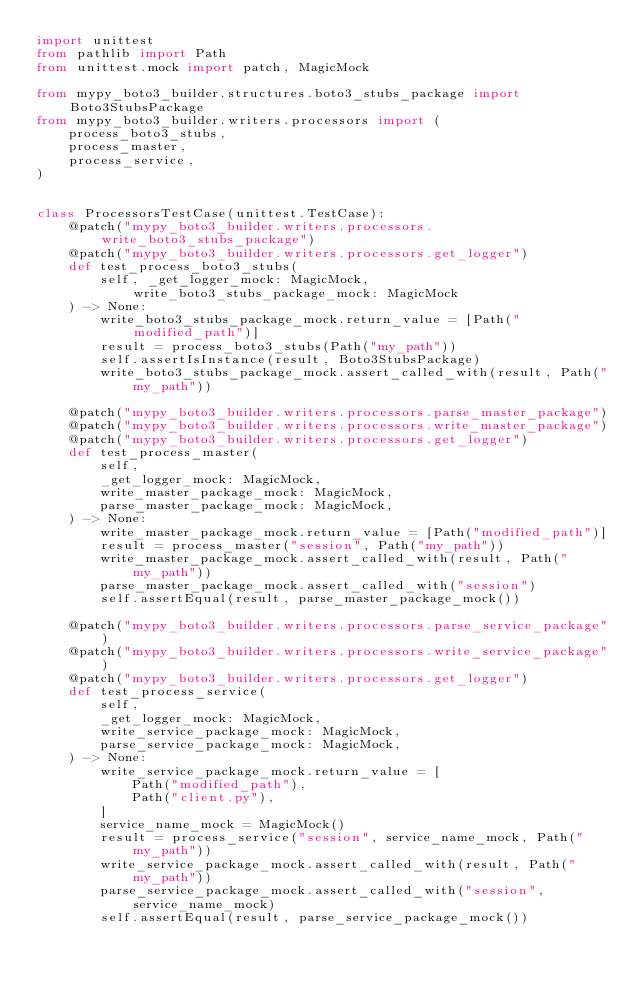<code> <loc_0><loc_0><loc_500><loc_500><_Python_>import unittest
from pathlib import Path
from unittest.mock import patch, MagicMock

from mypy_boto3_builder.structures.boto3_stubs_package import Boto3StubsPackage
from mypy_boto3_builder.writers.processors import (
    process_boto3_stubs,
    process_master,
    process_service,
)


class ProcessorsTestCase(unittest.TestCase):
    @patch("mypy_boto3_builder.writers.processors.write_boto3_stubs_package")
    @patch("mypy_boto3_builder.writers.processors.get_logger")
    def test_process_boto3_stubs(
        self, _get_logger_mock: MagicMock, write_boto3_stubs_package_mock: MagicMock
    ) -> None:
        write_boto3_stubs_package_mock.return_value = [Path("modified_path")]
        result = process_boto3_stubs(Path("my_path"))
        self.assertIsInstance(result, Boto3StubsPackage)
        write_boto3_stubs_package_mock.assert_called_with(result, Path("my_path"))

    @patch("mypy_boto3_builder.writers.processors.parse_master_package")
    @patch("mypy_boto3_builder.writers.processors.write_master_package")
    @patch("mypy_boto3_builder.writers.processors.get_logger")
    def test_process_master(
        self,
        _get_logger_mock: MagicMock,
        write_master_package_mock: MagicMock,
        parse_master_package_mock: MagicMock,
    ) -> None:
        write_master_package_mock.return_value = [Path("modified_path")]
        result = process_master("session", Path("my_path"))
        write_master_package_mock.assert_called_with(result, Path("my_path"))
        parse_master_package_mock.assert_called_with("session")
        self.assertEqual(result, parse_master_package_mock())

    @patch("mypy_boto3_builder.writers.processors.parse_service_package")
    @patch("mypy_boto3_builder.writers.processors.write_service_package")
    @patch("mypy_boto3_builder.writers.processors.get_logger")
    def test_process_service(
        self,
        _get_logger_mock: MagicMock,
        write_service_package_mock: MagicMock,
        parse_service_package_mock: MagicMock,
    ) -> None:
        write_service_package_mock.return_value = [
            Path("modified_path"),
            Path("client.py"),
        ]
        service_name_mock = MagicMock()
        result = process_service("session", service_name_mock, Path("my_path"))
        write_service_package_mock.assert_called_with(result, Path("my_path"))
        parse_service_package_mock.assert_called_with("session", service_name_mock)
        self.assertEqual(result, parse_service_package_mock())
</code> 